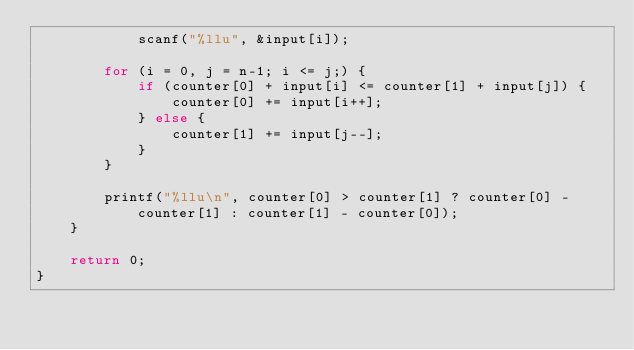Convert code to text. <code><loc_0><loc_0><loc_500><loc_500><_C_>            scanf("%llu", &input[i]);

        for (i = 0, j = n-1; i <= j;) {
            if (counter[0] + input[i] <= counter[1] + input[j]) {
                counter[0] += input[i++];
            } else {
                counter[1] += input[j--];
            }
        }

        printf("%llu\n", counter[0] > counter[1] ? counter[0] - counter[1] : counter[1] - counter[0]);
    }

    return 0;
}
</code> 